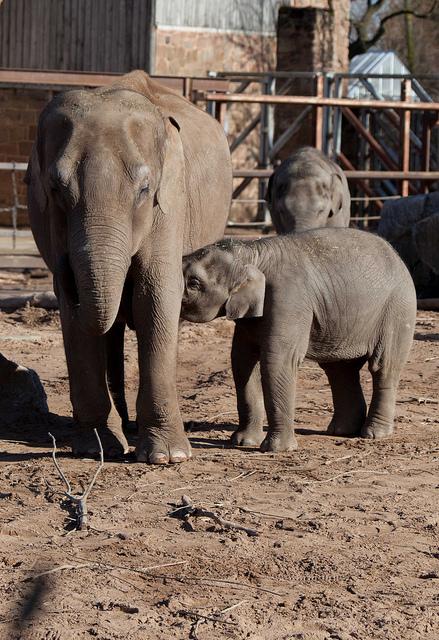What kind of ground are the elephants standing on?
Keep it brief. Dirt. How many different sizes of elephants are visible?
Keep it brief. 3. Are all these elephants full grown?
Answer briefly. No. Is it springtime?
Keep it brief. Yes. What is the elephant on the left standing on?
Keep it brief. Dirt. 